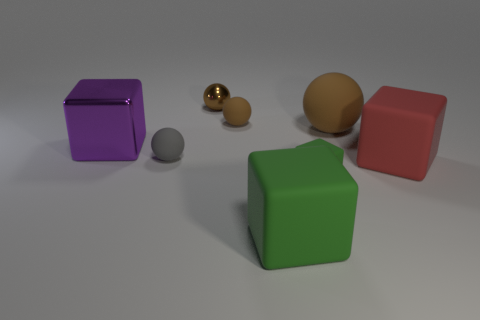Does the small rubber thing that is behind the large metallic block have the same color as the metal object that is behind the large matte ball?
Provide a short and direct response. Yes. Does the green thing that is right of the big green matte object have the same material as the cube that is behind the red object?
Ensure brevity in your answer.  No. The red rubber object is what size?
Your response must be concise. Large. There is a rubber ball in front of the metallic thing left of the tiny brown metallic ball that is left of the big red block; what is its size?
Provide a succinct answer. Small. Is there another large purple object that has the same material as the large purple object?
Provide a succinct answer. No. What is the shape of the large purple object?
Make the answer very short. Cube. The large sphere that is the same material as the large green object is what color?
Your answer should be compact. Brown. How many green objects are tiny matte objects or metallic blocks?
Give a very brief answer. 1. Are there more red matte things than matte things?
Offer a very short reply. No. How many objects are large cubes in front of the purple thing or small objects that are right of the gray object?
Your answer should be compact. 5. 